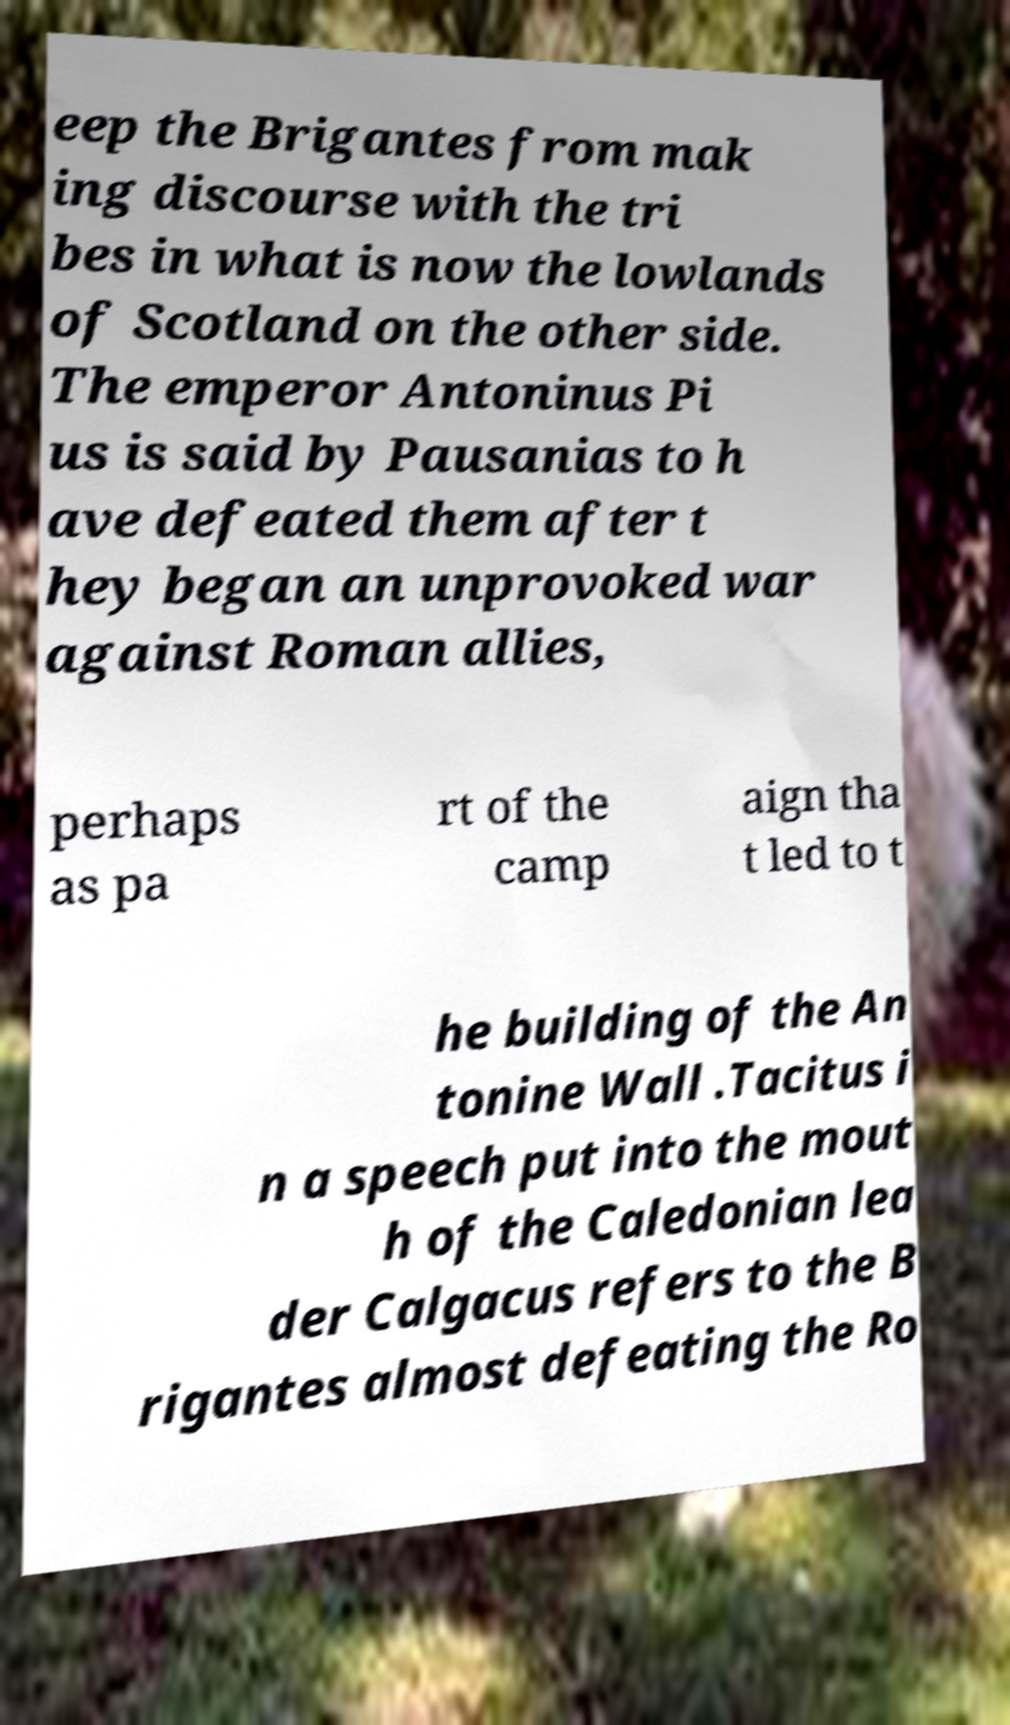Could you assist in decoding the text presented in this image and type it out clearly? eep the Brigantes from mak ing discourse with the tri bes in what is now the lowlands of Scotland on the other side. The emperor Antoninus Pi us is said by Pausanias to h ave defeated them after t hey began an unprovoked war against Roman allies, perhaps as pa rt of the camp aign tha t led to t he building of the An tonine Wall .Tacitus i n a speech put into the mout h of the Caledonian lea der Calgacus refers to the B rigantes almost defeating the Ro 